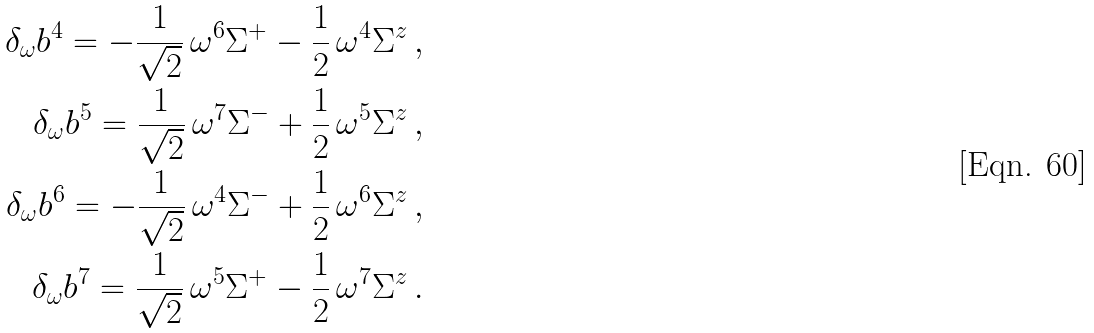Convert formula to latex. <formula><loc_0><loc_0><loc_500><loc_500>\delta _ { \omega } b ^ { 4 } = - \frac { 1 } { \sqrt { 2 } } \, \omega ^ { 6 } \Sigma ^ { + } - \frac { 1 } { 2 } \, \omega ^ { 4 } \Sigma ^ { z } & \, , \\ \delta _ { \omega } b ^ { 5 } = \frac { 1 } { \sqrt { 2 } } \, \omega ^ { 7 } \Sigma ^ { - } + \frac { 1 } { 2 } \, \omega ^ { 5 } \Sigma ^ { z } & \, , \\ \delta _ { \omega } b ^ { 6 } = - \frac { 1 } { \sqrt { 2 } } \, \omega ^ { 4 } \Sigma ^ { - } + \frac { 1 } { 2 } \, \omega ^ { 6 } \Sigma ^ { z } & \, , \\ \delta _ { \omega } b ^ { 7 } = \frac { 1 } { \sqrt { 2 } } \, \omega ^ { 5 } \Sigma ^ { + } - \frac { 1 } { 2 } \, \omega ^ { 7 } \Sigma ^ { z } & \, .</formula> 